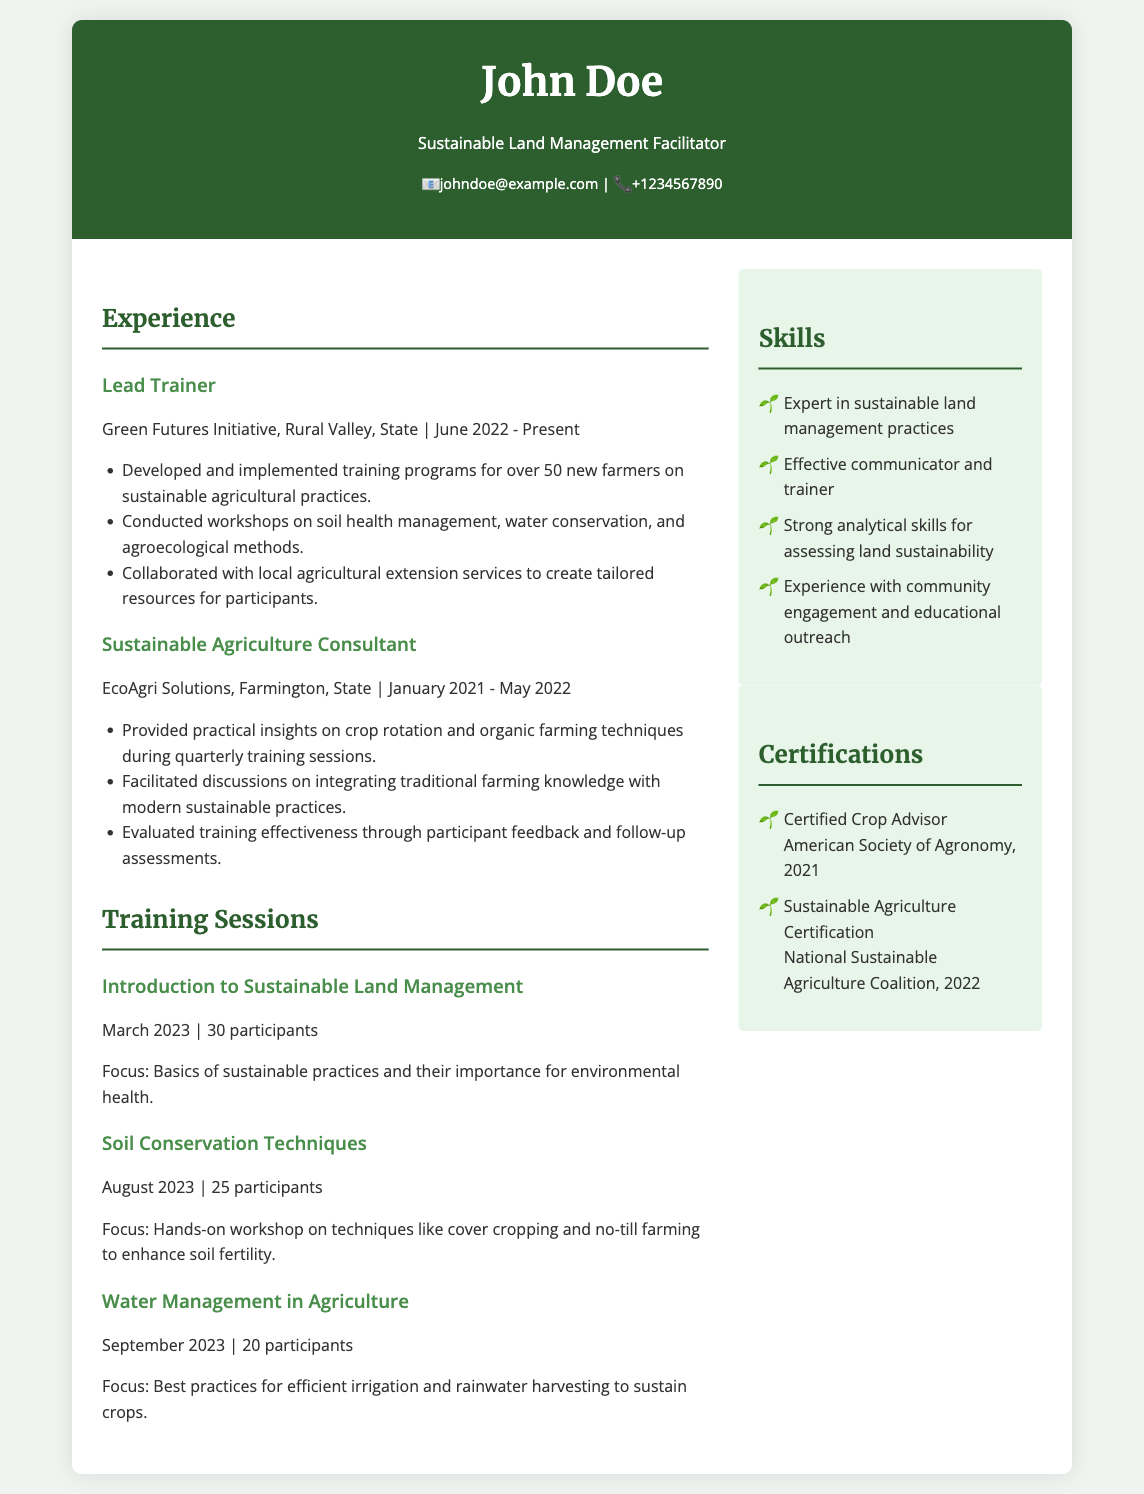what is the name of the facilitator? The name of the facilitator is mentioned in the header of the document.
Answer: John Doe how many participants attended the "Introduction to Sustainable Land Management" session? The number of participants for this session is given in the training sessions section.
Answer: 30 participants which organization did the facilitator work for as a Lead Trainer? The employment organization is stated under the experience section for the Lead Trainer position.
Answer: Green Futures Initiative when did the "Soil Conservation Techniques" training session take place? The date of the training session is provided in the training sessions section.
Answer: August 2023 what is one focus area of the "Water Management in Agriculture" session? The focus area is described in the training sessions section for that specific session.
Answer: Best practices for efficient irrigation how many new farmers were trained in total across all training sessions mentioned? To find the total number of farmers trained, sum the participants from each session listed.
Answer: 75 participants what is one skill listed under the skills section? The skills section includes various competencies related to the facilitator's expertise.
Answer: Expert in sustainable land management practices which certification was obtained in 2022? The certification with the date is provided in the certifications section.
Answer: Sustainable Agriculture Certification 